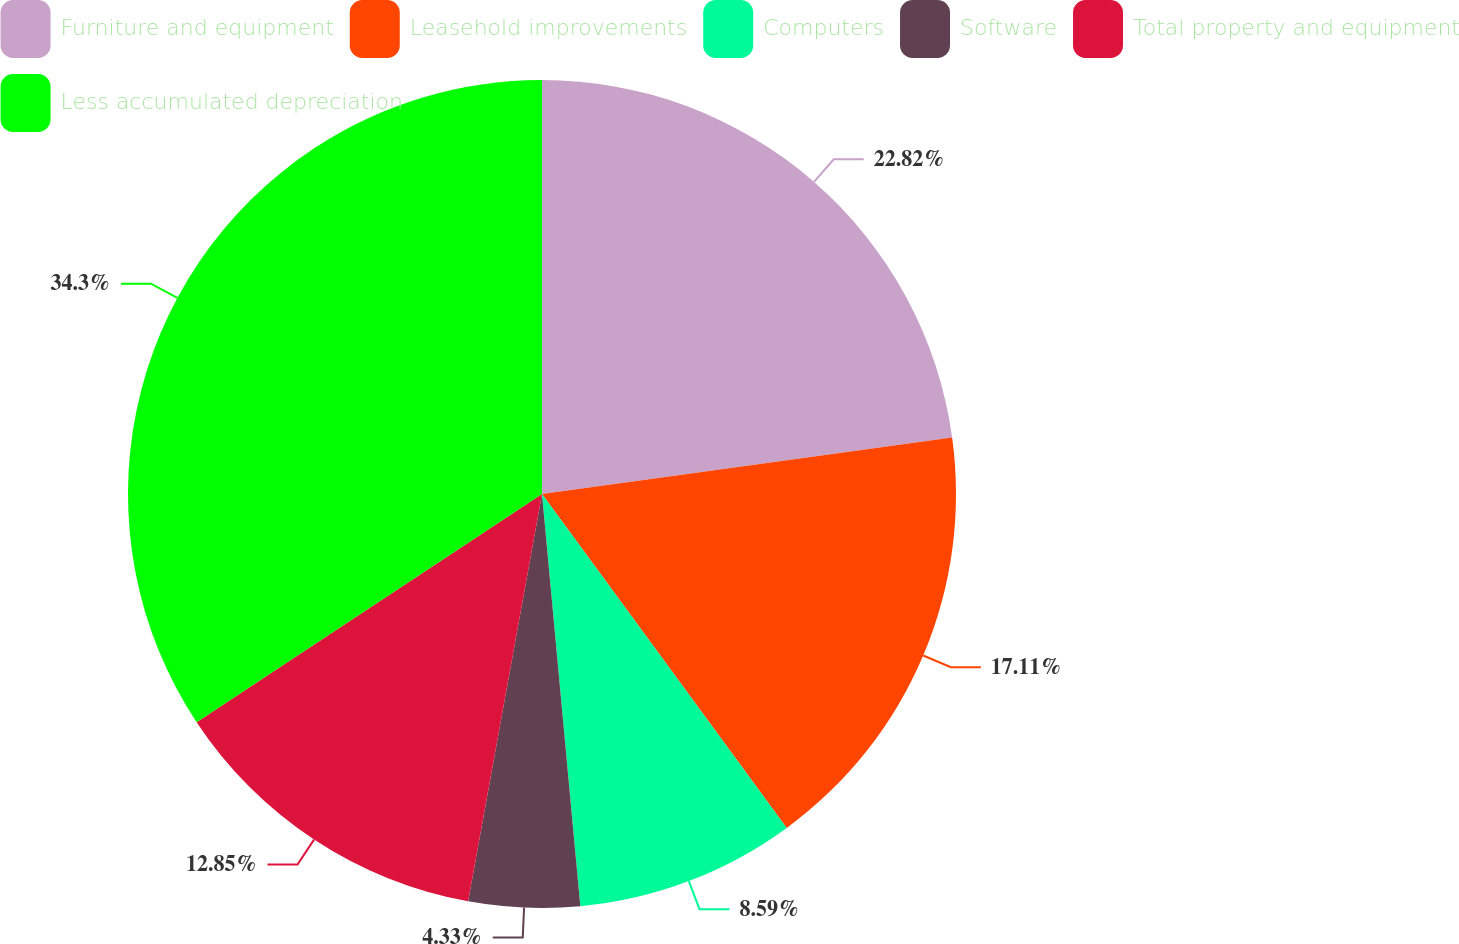Convert chart. <chart><loc_0><loc_0><loc_500><loc_500><pie_chart><fcel>Furniture and equipment<fcel>Leasehold improvements<fcel>Computers<fcel>Software<fcel>Total property and equipment<fcel>Less accumulated depreciation<nl><fcel>22.82%<fcel>17.11%<fcel>8.59%<fcel>4.33%<fcel>12.85%<fcel>34.29%<nl></chart> 